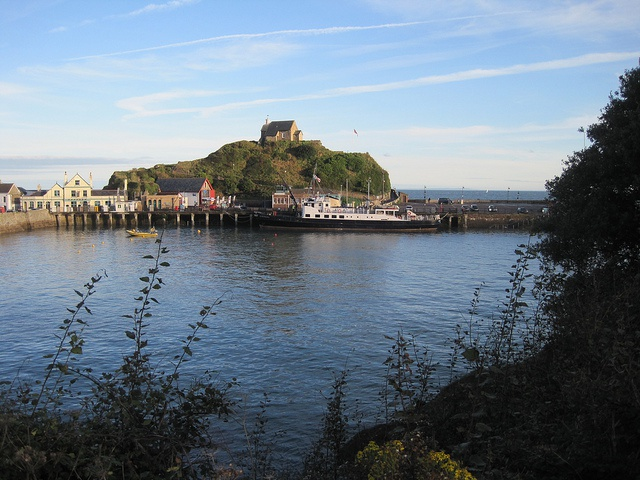Describe the objects in this image and their specific colors. I can see boat in lightblue, black, gray, lightgray, and darkgray tones, car in lightblue, black, gray, and darkblue tones, boat in lightblue, tan, and olive tones, car in lightblue, gray, maroon, and black tones, and car in lightblue, black, and gray tones in this image. 